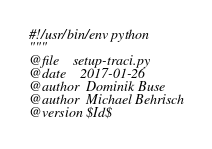<code> <loc_0><loc_0><loc_500><loc_500><_Python_>#!/usr/bin/env python
"""
@file    setup-traci.py
@date    2017-01-26
@author  Dominik Buse
@author  Michael Behrisch
@version $Id$
</code> 